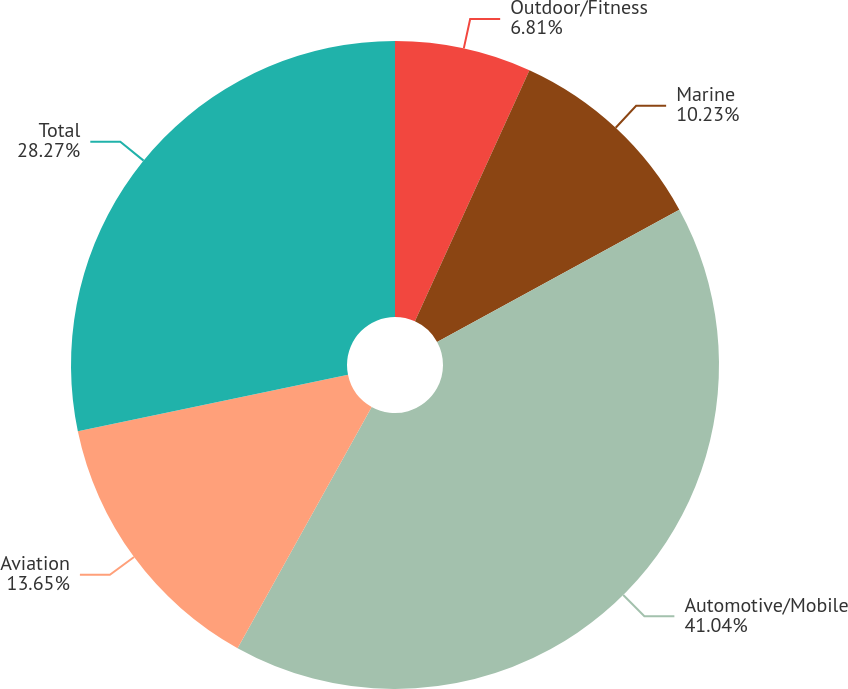Convert chart to OTSL. <chart><loc_0><loc_0><loc_500><loc_500><pie_chart><fcel>Outdoor/Fitness<fcel>Marine<fcel>Automotive/Mobile<fcel>Aviation<fcel>Total<nl><fcel>6.81%<fcel>10.23%<fcel>41.03%<fcel>13.65%<fcel>28.27%<nl></chart> 